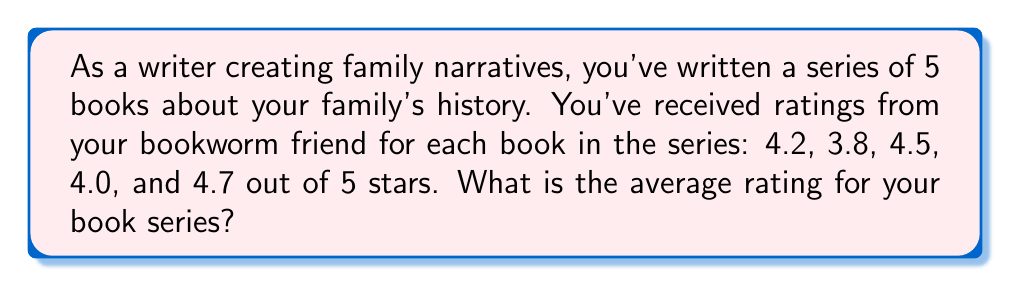Could you help me with this problem? To find the average rating of the book series, we need to:

1. Sum up all the individual ratings
2. Divide the sum by the total number of books

Let's break it down step-by-step:

1. Sum of ratings:
   $$4.2 + 3.8 + 4.5 + 4.0 + 4.7 = 21.2$$

2. Number of books: 5

3. Calculate the average:
   $$\text{Average} = \frac{\text{Sum of ratings}}{\text{Number of books}}$$
   $$\text{Average} = \frac{21.2}{5}$$
   $$\text{Average} = 4.24$$

Therefore, the average rating for your book series is 4.24 out of 5 stars.
Answer: $4.24$ stars 